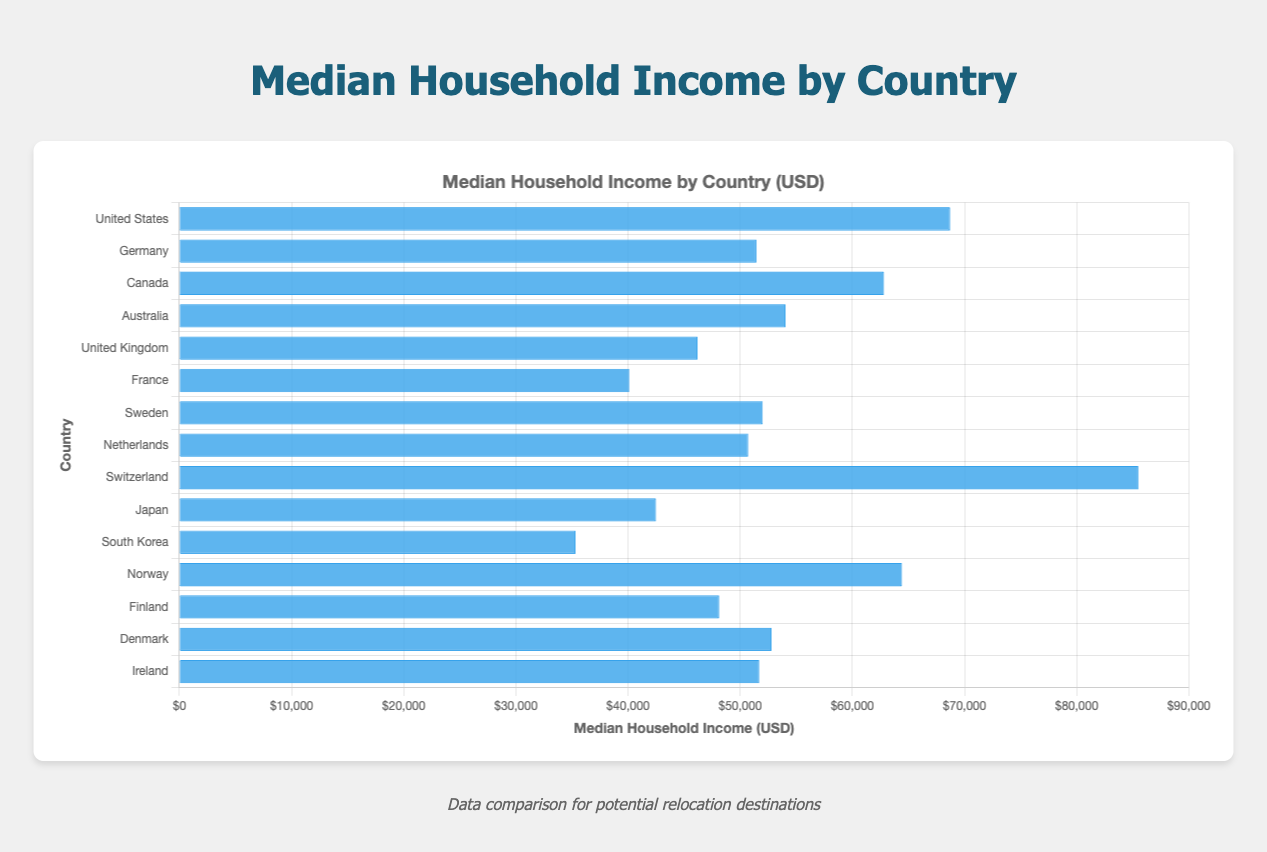Which country has the highest median household income? The country with the highest bar represents the country with the highest median household income. In this chart, Switzerland has the highest bar.
Answer: Switzerland Which country has the lowest median household income? The country with the shortest bar represents the country with the lowest median household income. In this chart, South Korea has the shortest bar.
Answer: South Korea Is the median household income in Germany higher or lower than in Canada? First, locate the bars for Germany and Canada. The height of Canada's bar is greater than Germany's bar, indicating that Canada has a higher median household income than Germany.
Answer: Lower How much greater is the median household income in the United States compared to Germany? Subtract Germany's median household income from the United States' median household income: 68703 - 51444 = 17259.
Answer: 17259 USD What's the average median household income of the top 3 countries? Identify the top 3 countries with the highest income: Switzerland (85500), United States (68703), and Canada (62800). The average is (85500 + 68703 + 62800) / 3 = 72334.33.
Answer: 72334.33 USD Which countries have a median household income between 50000 and 60000 USD? Identify the bars between 50000 USD and 60000 USD. These countries are Germany, Denmark, and Australia.
Answer: Germany, Denmark, Australia How does Finland's median household income compare to that of Ireland? Locate the bars for Finland and Ireland. Ireland's bar is slightly higher than Finland's, indicating a greater median household income in Ireland.
Answer: Lower What is the total median household income for all the countries listed? Sum the median household incomes for all countries: 68703 + 51444 + 62800 + 54044 + 46200 + 40112 + 52000 + 50713 + 85500 + 42500 + 35320 + 64400 + 48130 + 52800 + 51700 = 811366.
Answer: 811366 USD Which country is closer in median household income to Ireland, Germany or the United Kingdom? Find the differences: Ireland is 51700, Germany is 51444, and the United Kingdom is 46200. The difference between Ireland and Germany is 256, while the difference between Ireland and the UK is 5500; therefore, Germany is closer.
Answer: Germany What is the difference in median household income between the country with the second-highest income and the country with the second-lowest income? Identify the second-highest income (United States, 68703) and the second-lowest income (Japan, 42500). The difference is 68703 - 42500 = 26203.
Answer: 26203 USD 